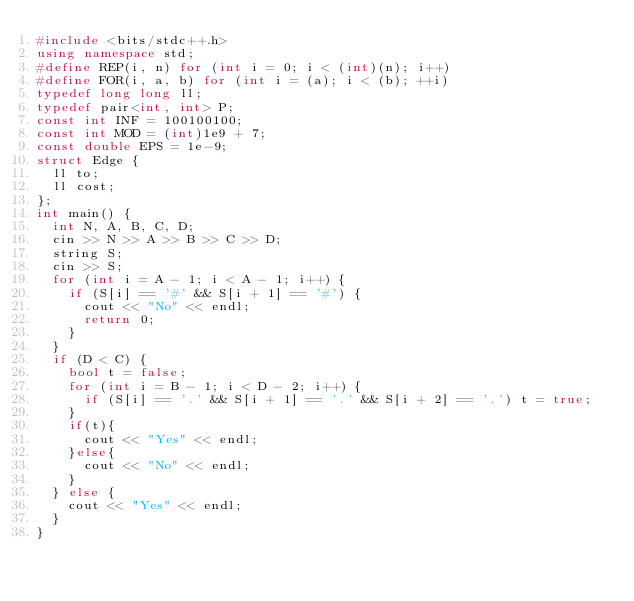Convert code to text. <code><loc_0><loc_0><loc_500><loc_500><_C++_>#include <bits/stdc++.h>
using namespace std;
#define REP(i, n) for (int i = 0; i < (int)(n); i++)
#define FOR(i, a, b) for (int i = (a); i < (b); ++i)
typedef long long ll;
typedef pair<int, int> P;
const int INF = 100100100;
const int MOD = (int)1e9 + 7;
const double EPS = 1e-9;
struct Edge {
  ll to;
  ll cost;
};
int main() {
  int N, A, B, C, D;
  cin >> N >> A >> B >> C >> D;
  string S;
  cin >> S;
  for (int i = A - 1; i < A - 1; i++) {
    if (S[i] == '#' && S[i + 1] == '#') {
      cout << "No" << endl;
      return 0;
    }
  }
  if (D < C) {
    bool t = false;
    for (int i = B - 1; i < D - 2; i++) {
      if (S[i] == '.' && S[i + 1] == '.' && S[i + 2] == '.') t = true;
    }
    if(t){
      cout << "Yes" << endl;
    }else{
      cout << "No" << endl;
    }
  } else {
    cout << "Yes" << endl;
  }
}</code> 